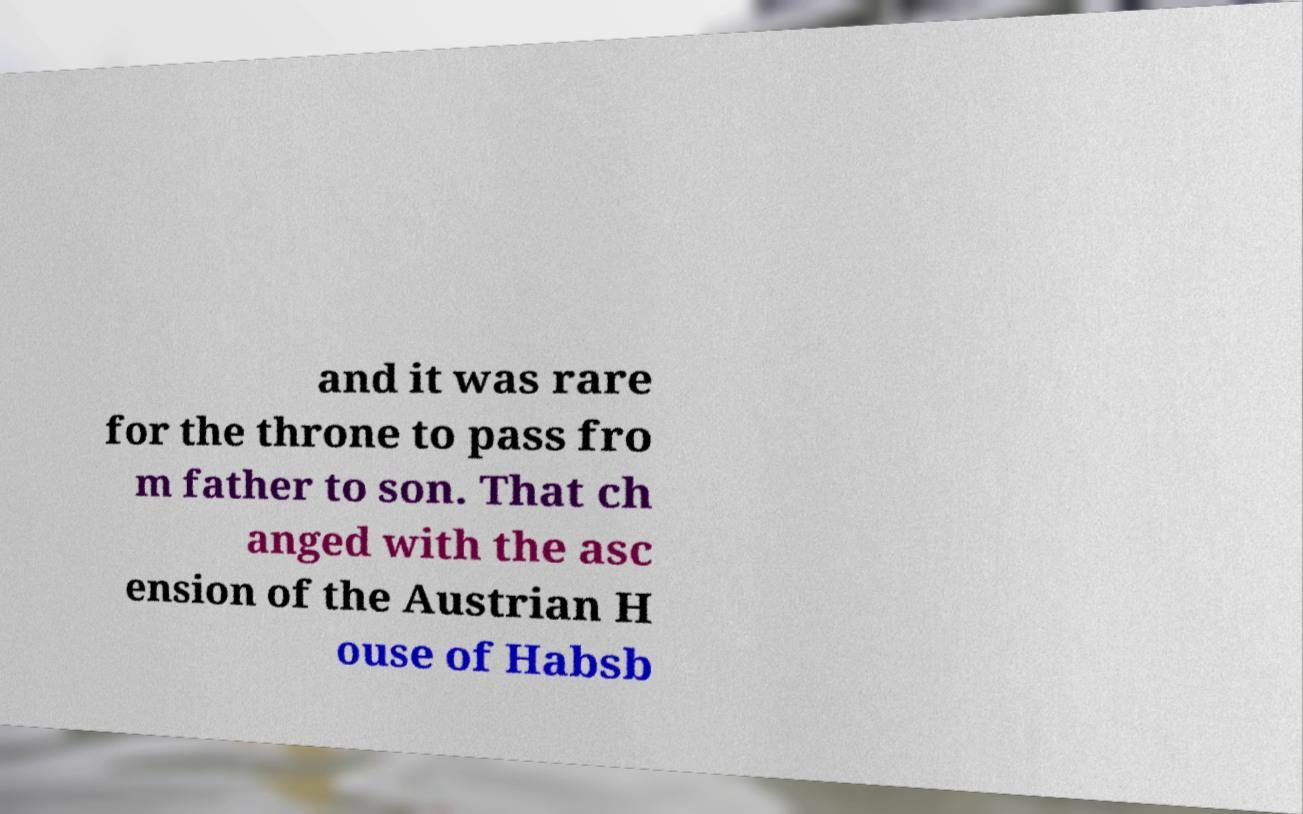Can you accurately transcribe the text from the provided image for me? and it was rare for the throne to pass fro m father to son. That ch anged with the asc ension of the Austrian H ouse of Habsb 